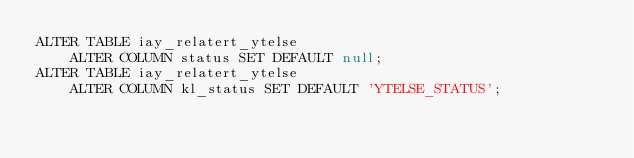<code> <loc_0><loc_0><loc_500><loc_500><_SQL_>ALTER TABLE iay_relatert_ytelse
    ALTER COLUMN status SET DEFAULT null;
ALTER TABLE iay_relatert_ytelse
    ALTER COLUMN kl_status SET DEFAULT 'YTELSE_STATUS';
</code> 